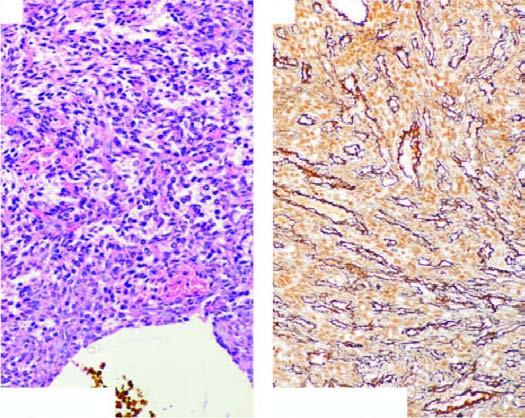do cells surround the vascular lumina in a whorled fashion, highlighted by reticulin stain?
Answer the question using a single word or phrase. Yes 